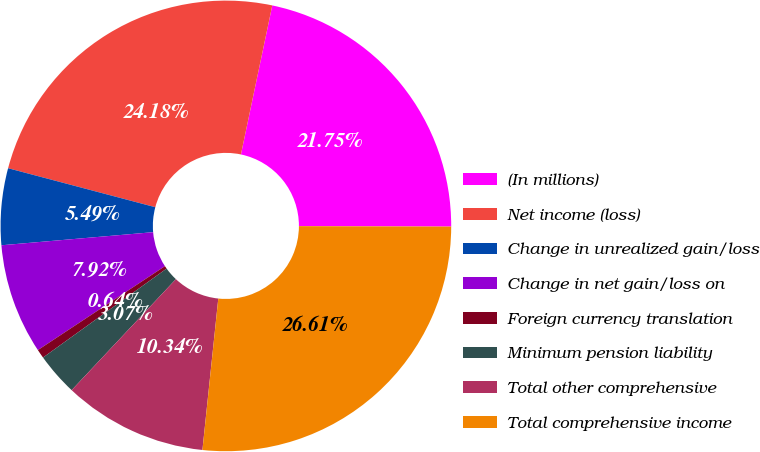Convert chart. <chart><loc_0><loc_0><loc_500><loc_500><pie_chart><fcel>(In millions)<fcel>Net income (loss)<fcel>Change in unrealized gain/loss<fcel>Change in net gain/loss on<fcel>Foreign currency translation<fcel>Minimum pension liability<fcel>Total other comprehensive<fcel>Total comprehensive income<nl><fcel>21.75%<fcel>24.18%<fcel>5.49%<fcel>7.92%<fcel>0.64%<fcel>3.07%<fcel>10.34%<fcel>26.61%<nl></chart> 